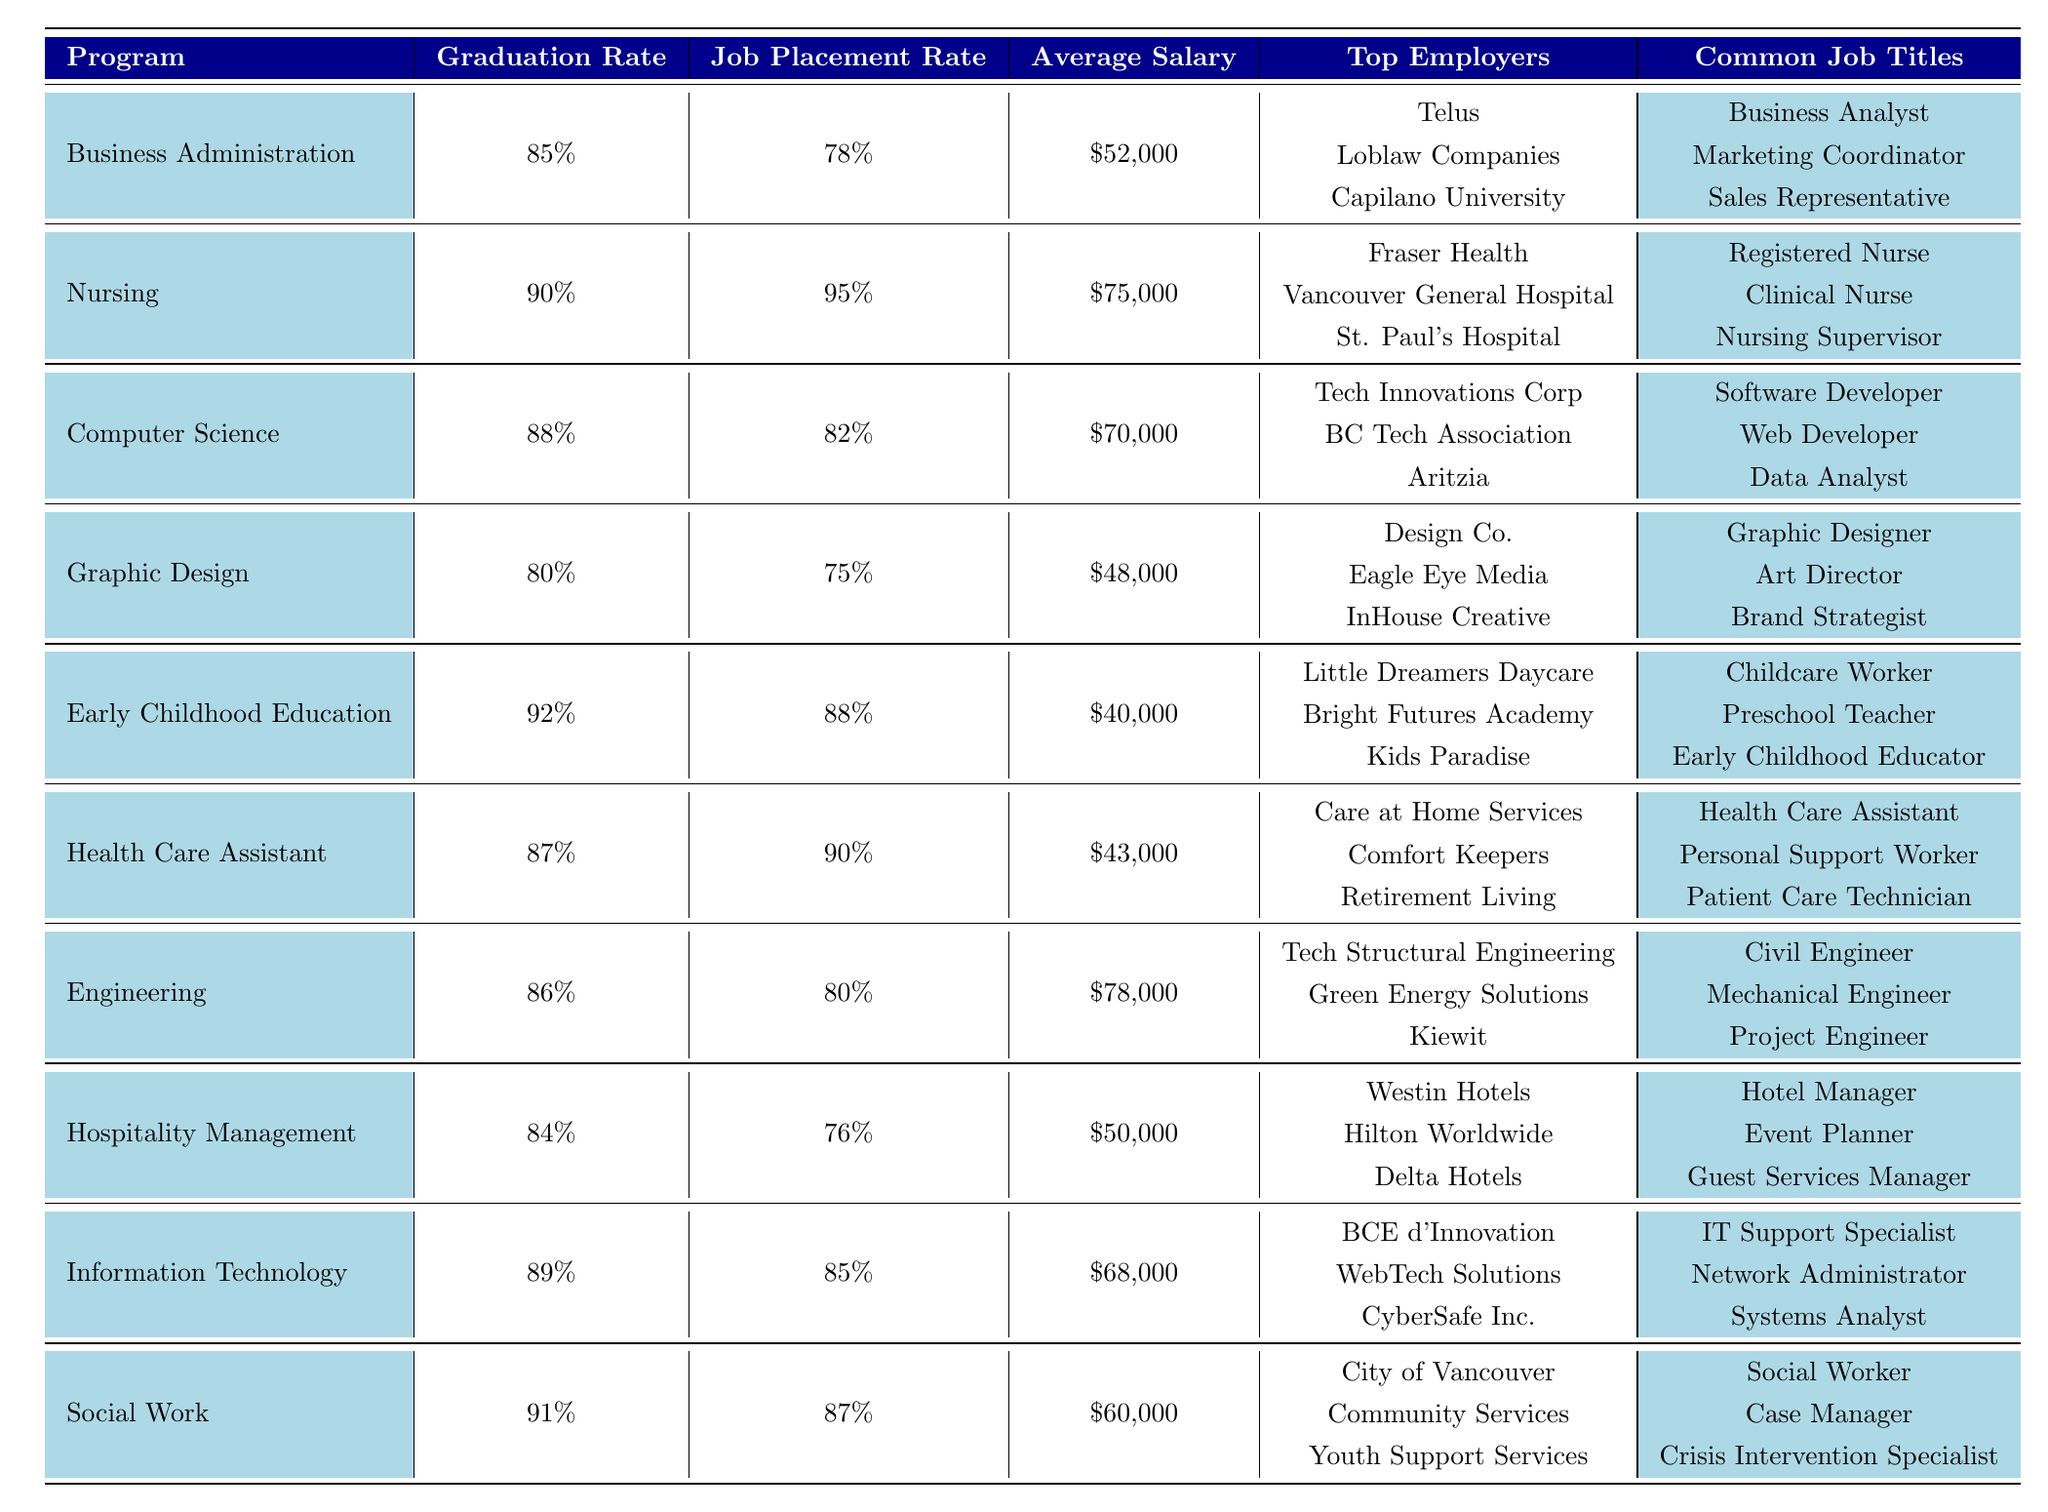What is the job placement rate for the Nursing program? The table shows the job placement rate in the "Job Placement Rate" column for the Nursing program. It is explicitly listed as 95%.
Answer: 95% Which program has the highest average salary? By looking at the "Average Salary" column, the highest value is $78,000, which corresponds to the Engineering program.
Answer: Engineering What is the graduation rate for the Graphic Design program? The graduation rate for the Graphic Design program is found in the "Graduation Rate" column, where it is stated as 80%.
Answer: 80% How many programs have a job placement rate higher than 85%? To find this, I check the "Job Placement Rate" column for rates higher than 85%. The programs with rates higher than 85% are Nursing (95%), Health Care Assistant (90%), Information Technology (85%), and Social Work (87%). This gives a total of 4 programs.
Answer: 4 What is the average salary for degrees with a job placement rate below 80%? The programs with job placement rates below 80% are Graphic Design (75%) and Hospitality Management (76%). Their average salaries are $48,000 and $50,000, respectively. Summing these salaries gives $98,000, and dividing by the number of programs (2) gives an average salary of $49,000.
Answer: $49,000 Can we say that most graduates from Early Childhood Education found jobs? The job placement rate for Early Childhood Education is 88%, which is significantly high. Therefore, it can be concluded that most graduates found jobs.
Answer: Yes What are the common job titles for graduates in Information Technology? The "Common Job Titles" column lists the job titles for graduates in Information Technology as IT Support Specialist, Network Administrator, and Systems Analyst.
Answer: IT Support Specialist, Network Administrator, Systems Analyst Which program shows the least number of common job titles listed? By examining the "Common Job Titles" column, both the Early Childhood Education and Nursing programs list three common job titles, while all other programs also list three. Therefore, there is no one program with fewer than three, so they are equal.
Answer: Equal (3 titles) If we were to rank the programs by job placement rates, what would be the top three? Starting from the "Job Placement Rate" column, the highest three rates are: Nursing (95%), Health Care Assistant (90%), and Social Work (87%). Thus, these are the top three programs by job placement rate.
Answer: Nursing, Health Care Assistant, Social Work What is the difference in job placement rates between the Business Administration and Computer Science programs? The job placement rates are 78% for Business Administration and 82% for Computer Science. To find the difference, I subtract 78 from 82, which equals 4%.
Answer: 4% Are there any programs with a graduation rate below 85%? Checking the "Graduation Rate" column, the programs with rates below 85% are Graphic Design (80%) and Hospitality Management (84%). Therefore, the answer is yes.
Answer: Yes 